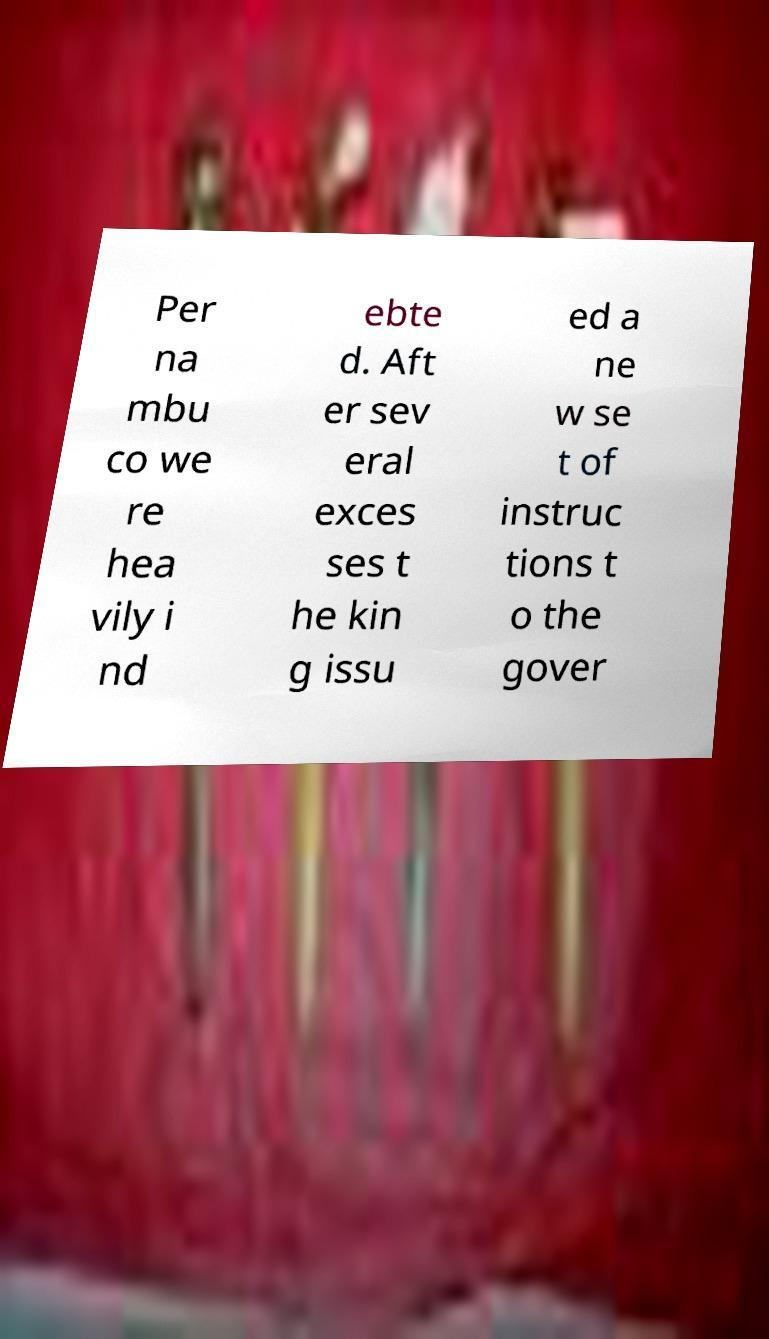Please read and relay the text visible in this image. What does it say? Per na mbu co we re hea vily i nd ebte d. Aft er sev eral exces ses t he kin g issu ed a ne w se t of instruc tions t o the gover 